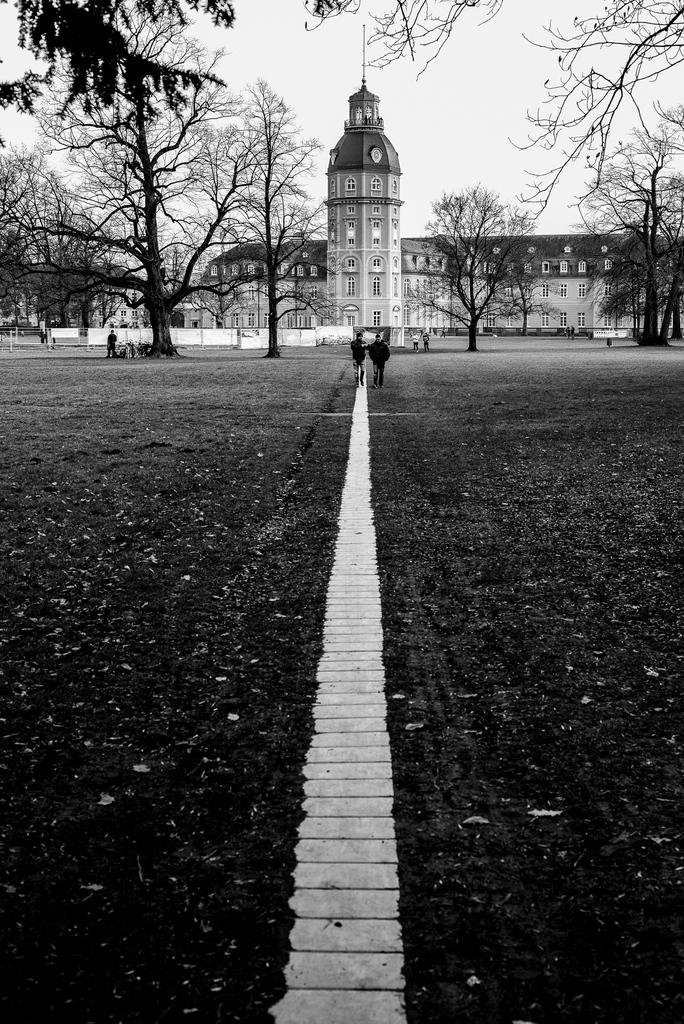How many people are in the image? There is a group of people in the image, but the exact number cannot be determined from the provided facts. What can be seen in the background of the image? There are trees and buildings in the background of the image. What is the color scheme of the image? The image is in black and white. How many chairs are visible in the image? There is no mention of chairs in the provided facts, so we cannot determine the number of chairs in the image. What is the group of people's collective desire in the image? There is no information about the group's desires in the provided facts, so we cannot determine their collective desire from the image. 